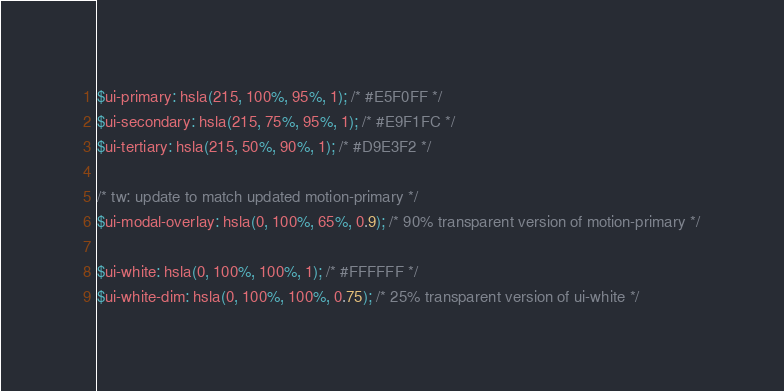Convert code to text. <code><loc_0><loc_0><loc_500><loc_500><_CSS_>$ui-primary: hsla(215, 100%, 95%, 1); /* #E5F0FF */
$ui-secondary: hsla(215, 75%, 95%, 1); /* #E9F1FC */
$ui-tertiary: hsla(215, 50%, 90%, 1); /* #D9E3F2 */

/* tw: update to match updated motion-primary */
$ui-modal-overlay: hsla(0, 100%, 65%, 0.9); /* 90% transparent version of motion-primary */

$ui-white: hsla(0, 100%, 100%, 1); /* #FFFFFF */
$ui-white-dim: hsla(0, 100%, 100%, 0.75); /* 25% transparent version of ui-white */</code> 